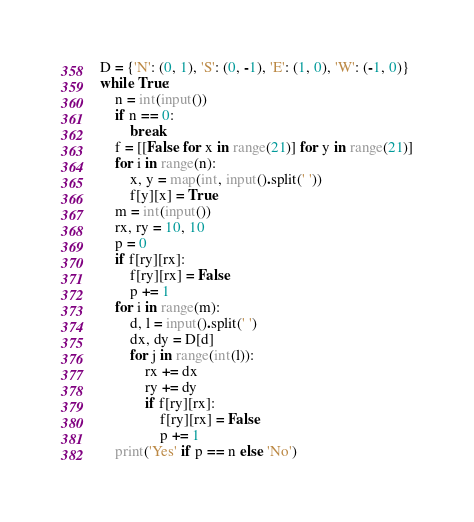Convert code to text. <code><loc_0><loc_0><loc_500><loc_500><_Python_>D = {'N': (0, 1), 'S': (0, -1), 'E': (1, 0), 'W': (-1, 0)}
while True:
    n = int(input())
    if n == 0:
        break
    f = [[False for x in range(21)] for y in range(21)]
    for i in range(n):
        x, y = map(int, input().split(' '))
        f[y][x] = True
    m = int(input())
    rx, ry = 10, 10
    p = 0
    if f[ry][rx]:
        f[ry][rx] = False
        p += 1
    for i in range(m):
        d, l = input().split(' ')
        dx, dy = D[d]
        for j in range(int(l)):
            rx += dx
            ry += dy
            if f[ry][rx]:
                f[ry][rx] = False
                p += 1
    print('Yes' if p == n else 'No')</code> 